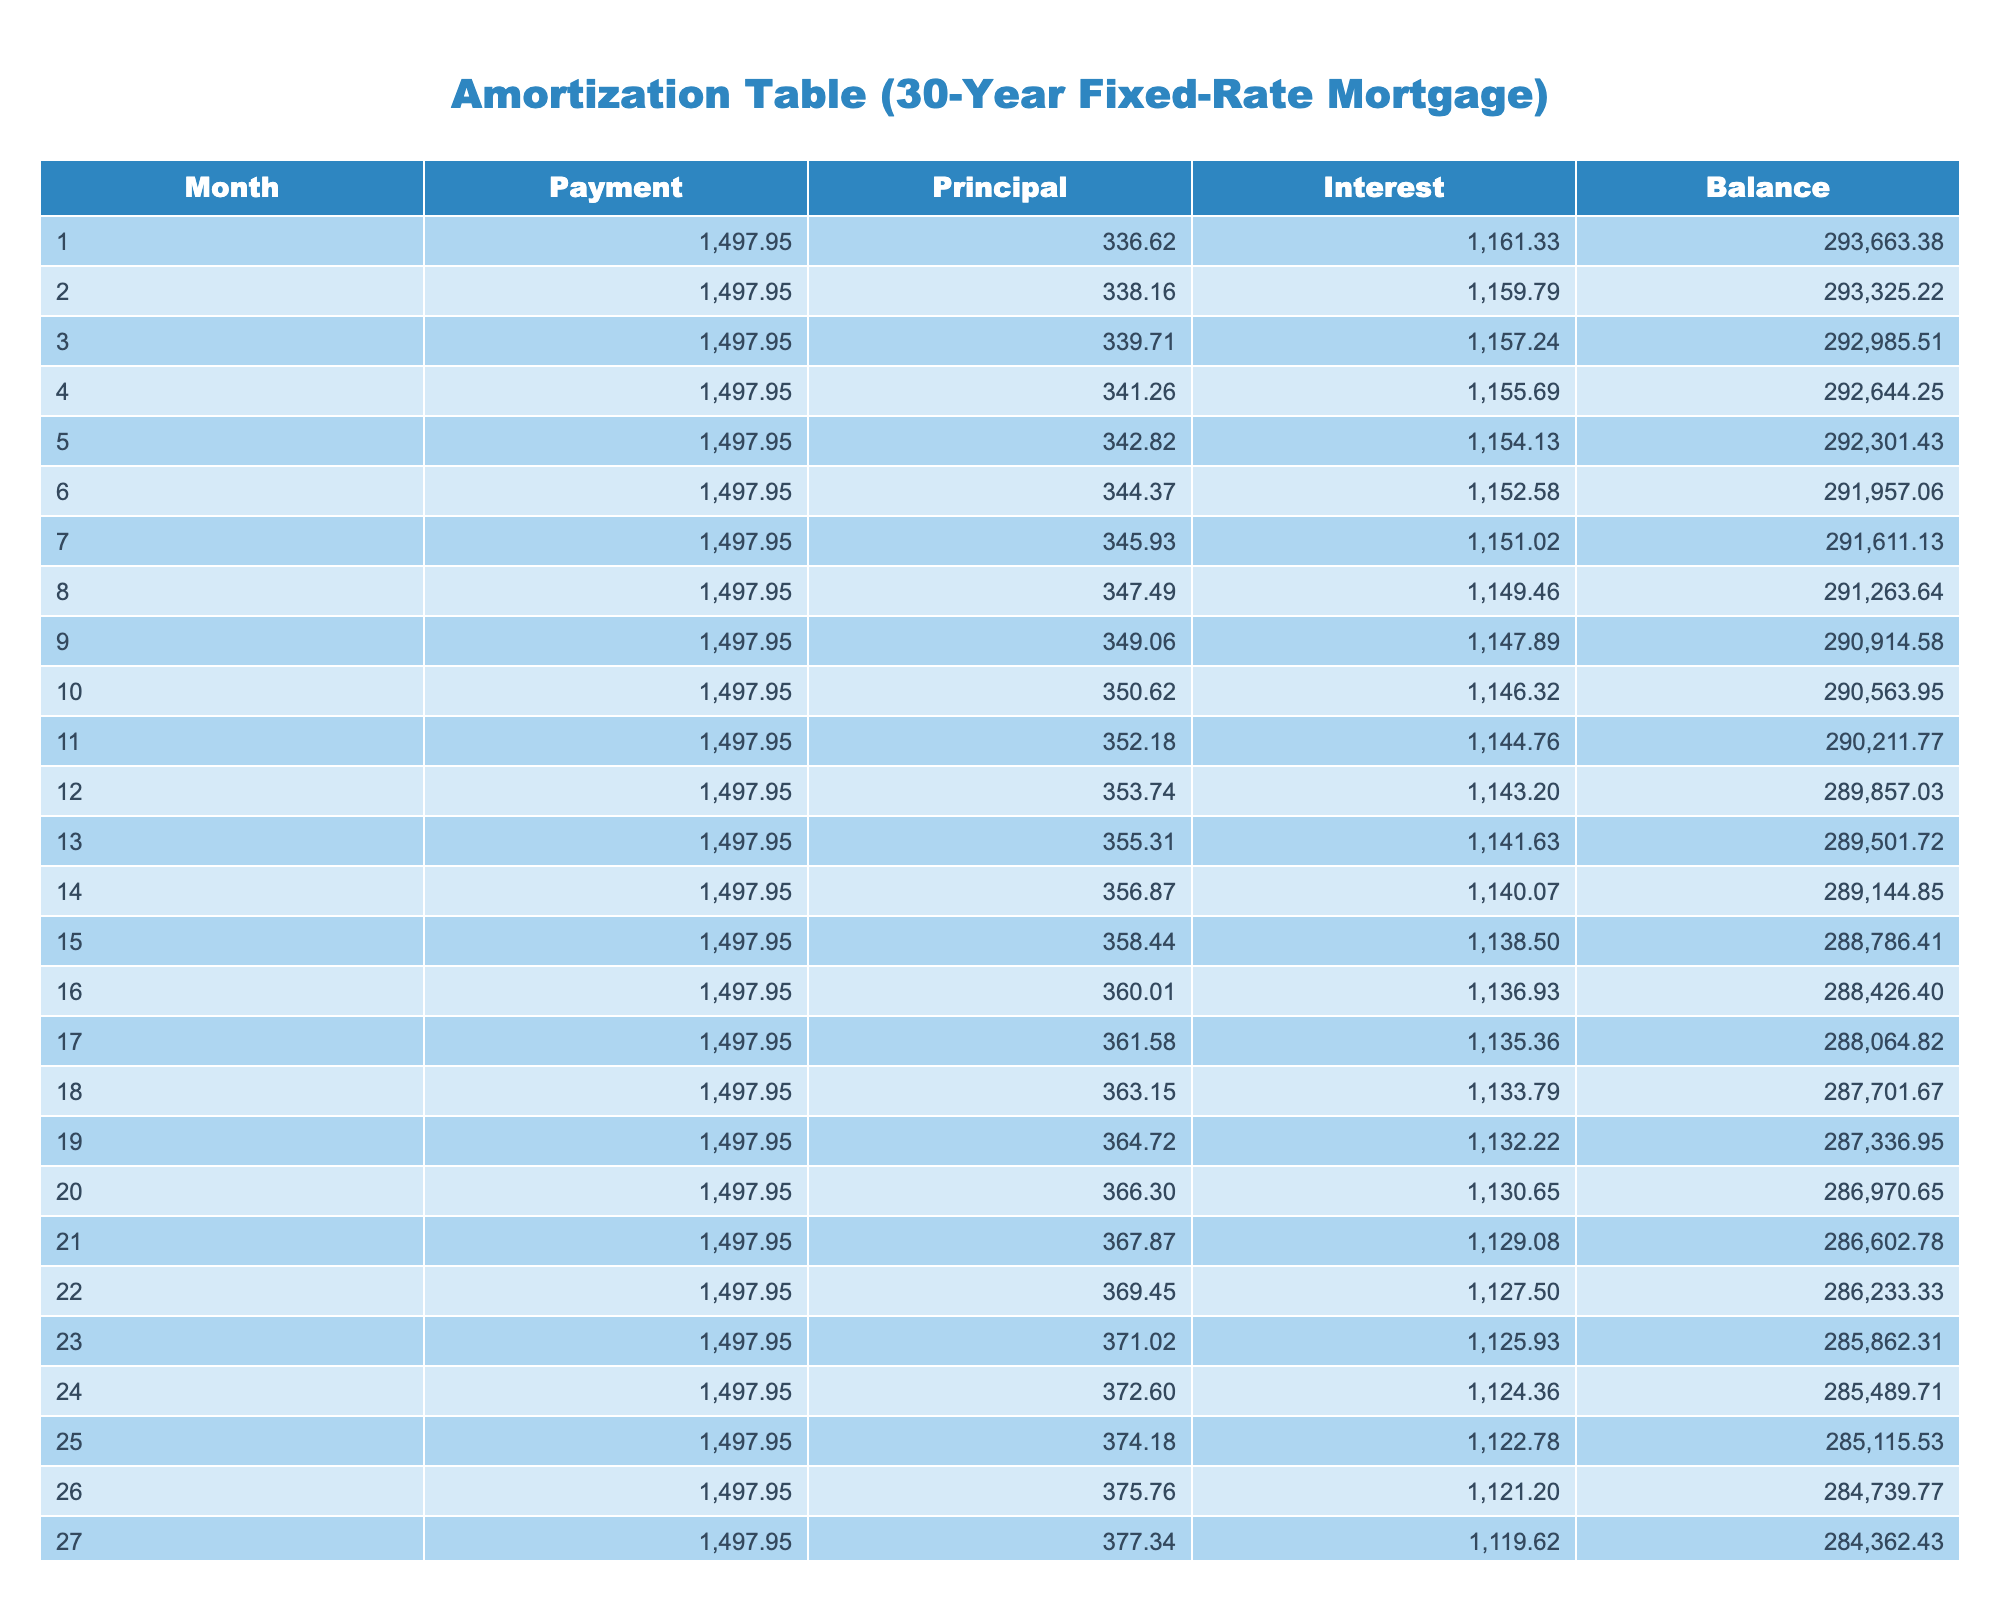What is the total payment for the first month? According to the table, the payment listed for the first month is 1497.95.
Answer: 1497.95 How much principal is paid off in the 5th month? From the table, the principal amount for the 5th month is 342.82.
Answer: 342.82 What is the balance remaining after the 10th month? The table states that the remaining balance after the 10th month is 290563.95.
Answer: 290563.95 Is the interest paid in the 7th month greater than the interest paid in the 16th month? The interest paid in the 7th month is 1151.02, while the interest paid in the 16th month is 1136.93. Since 1151.02 is greater than 1136.93, the answer is yes.
Answer: Yes What is the average principal paid over the first 30 months? First, add up all the principal amounts paid in the first 30 months and then divide by 30: (336.62 + 338.16 + 339.71 + ... + 382.08) = 10,207.30. Next, divide 10,207.30 by 30 to get the average: 10,207.30 / 30 = 340.24.
Answer: 340.24 What is the total interest paid in the first 12 months? To find this, add the interest for each of the first 12 months: (1161.33 + 1159.79 + ... + 1143.20). This sum equals 13,861.12.
Answer: 13861.12 How much is the payment amount for month 25? The table shows that the payment amount for the 25th month is 1497.95.
Answer: 1497.95 Does the balance after 24 months exceed 285,000? The remaining balance after 24 months is 285489.71. Since this is slightly above 285,000, the answer is yes.
Answer: Yes What is the difference between the principal payment in the 30th month and the principal payment in the 1st month? The principal payment in the 30th month is 382.08 and in the 1st month it is 336.62. The difference is: 382.08 - 336.62 = 45.46.
Answer: 45.46 